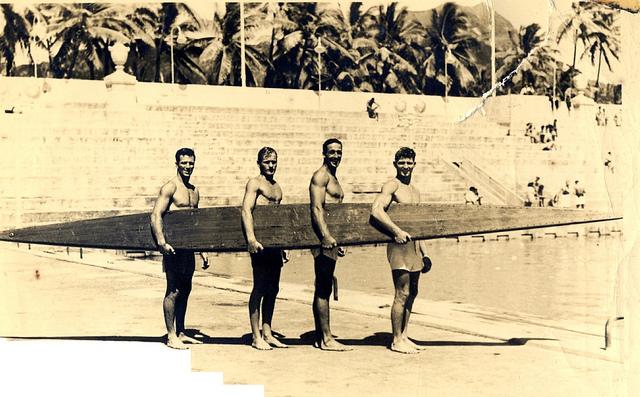How many people are in the photo?
Quick response, please. 4. How many people are wearing shirts?
Quick response, please. 0. What are the men holding?
Write a very short answer. Surfboard. 